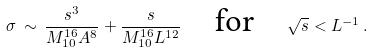Convert formula to latex. <formula><loc_0><loc_0><loc_500><loc_500>\sigma \, \sim \, \frac { s ^ { 3 } } { M _ { 1 0 } ^ { 1 6 } A ^ { 8 } } + \frac { s } { M _ { 1 0 } ^ { 1 6 } L ^ { 1 2 } } \quad \text {for} \quad \sqrt { s } < L ^ { - 1 } \, .</formula> 